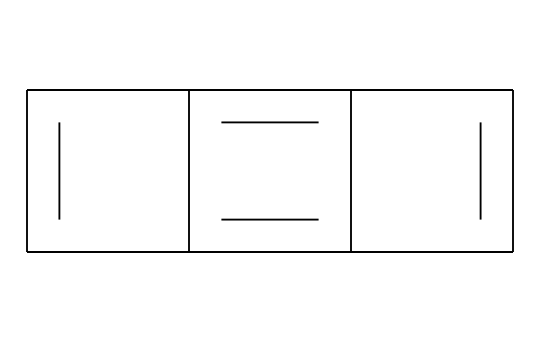What is the name of the chemical represented by the SMILES? The SMILES representation corresponds to a specific structure which is commonly known as graphite. This structure consists of multiple interconnected carbon atoms, indicative of its classification.
Answer: graphite How many carbon atoms are present in the structure? By analyzing the SMILES notation, each "C" stands for a carbon atom. After counting, there are a total of 12 carbon atoms in the representation.
Answer: 12 What type of molecular structure does this chemical exhibit? The chemical structure, as per the SMILES, exhibits a planar aromatic structure due to its interconnected double bonds and ring formations, characteristic of graphite.
Answer: planar aromatic What kind of properties does this structure impart as a lubricant? The layered structure of graphite results in low friction between the layers, enabling effective lubrication and heat dissipation when applied to film reel equipment.
Answer: low friction What does the cyclic nature of the structure indicate? The cyclic nature suggests that the structure is stable and contributes to its effectiveness as a lubricant, as it allows for smooth sliding between the layers without degradation.
Answer: stability How is this chemical suitable for film reel equipment? Its layered, planar structure allows it to reduce wear and tear through friction, making it ideal for reducing resistance in film reel mechanisms.
Answer: reduces friction 